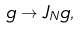Convert formula to latex. <formula><loc_0><loc_0><loc_500><loc_500>g \to J _ { N } g ,</formula> 